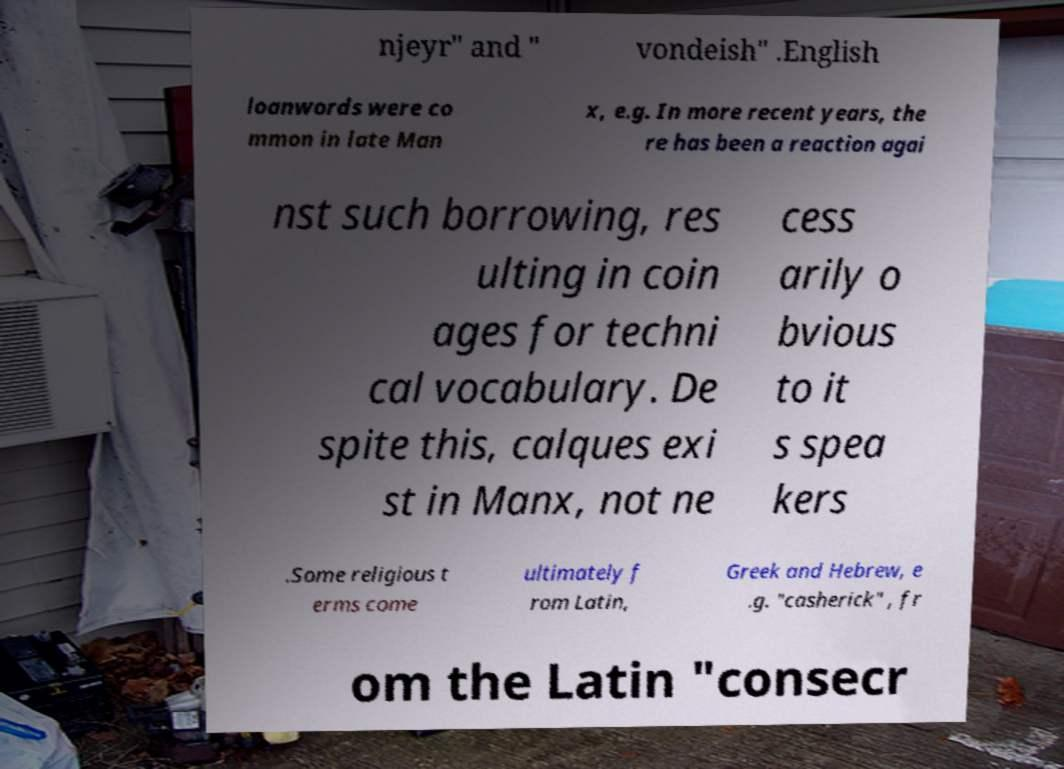Can you accurately transcribe the text from the provided image for me? njeyr" and " vondeish" .English loanwords were co mmon in late Man x, e.g. In more recent years, the re has been a reaction agai nst such borrowing, res ulting in coin ages for techni cal vocabulary. De spite this, calques exi st in Manx, not ne cess arily o bvious to it s spea kers .Some religious t erms come ultimately f rom Latin, Greek and Hebrew, e .g. "casherick" , fr om the Latin "consecr 